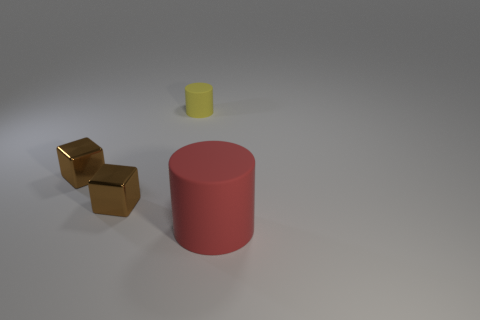Subtract all green cylinders. Subtract all blue blocks. How many cylinders are left? 2 Add 2 gray cubes. How many objects exist? 6 Add 1 small yellow matte things. How many small yellow matte things are left? 2 Add 2 shiny things. How many shiny things exist? 4 Subtract 0 red cubes. How many objects are left? 4 Subtract all red matte things. Subtract all small objects. How many objects are left? 0 